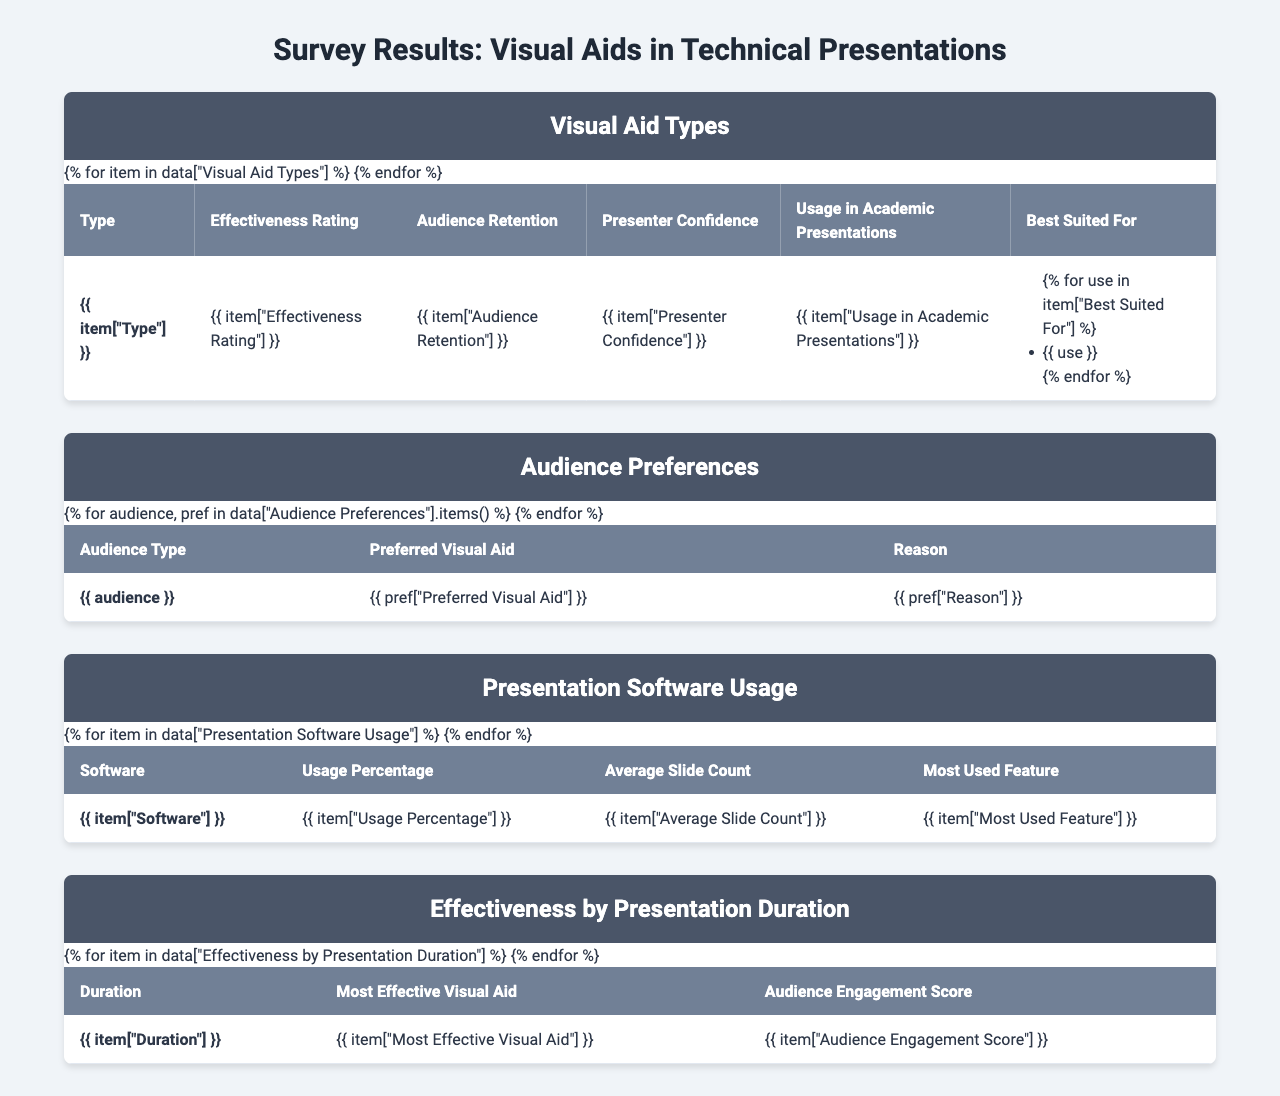What is the effectiveness rating for Interactive Demos? The table shows that the effectiveness rating for Interactive Demos is listed directly, which is 9.1.
Answer: 9.1 Which visual aid has the highest audience retention? The table indicates that Interactive Demos have the highest audience retention at 82%.
Answer: 82% How many audience members prefer Static Charts and Graphs? The table states that Faculty Members prefer Static Charts and Graphs, but does not provide a specific number of audience members, only their preference.
Answer: Not specified Which visual aid type is best suited for complex data? The table lists Infographics as being best suited for complex data.
Answer: Infographics What is the average effectiveness rating of all visual aids? The effectiveness ratings are 8.2 (Infographics), 7.8 (Animated Slides), 9.1 (Interactive Demos), 7.5 (Static Charts and Graphs), and 8.4 (Video Clips). The sum is 40. This gives an average effectiveness rating of 40/5 = 8.0.
Answer: 8.0 Do industry professionals prefer Video Clips as their primary visual aid? The table shows that industry professionals prefer Interactive Demos, not Video Clips, thus the answer is no.
Answer: No Which visual aid is most effective for presentations lasting 21-30 minutes? According to the table, the most effective visual aid for this duration is Interactive Demos, which has an audience engagement score of 8.9.
Answer: Interactive Demos What is the difference in effectiveness rating between Infographics and Static Charts and Graphs? From the table, Infographics have an effectiveness rating of 8.2 and Static Charts and Graphs have a rating of 7.5. The difference is 8.2 - 7.5 = 0.7.
Answer: 0.7 How many more audience members prefer Infographics over Animated Slides? The table shows Graduate Students prefer Infographics, while the preference for Animated Slides is not specified. Therefore, we cannot determine a numerical difference.
Answer: Not specified Which software has the highest usage percentage and what is that percentage? The table indicates that Microsoft PowerPoint has the highest usage percentage of 68%.
Answer: 68% 